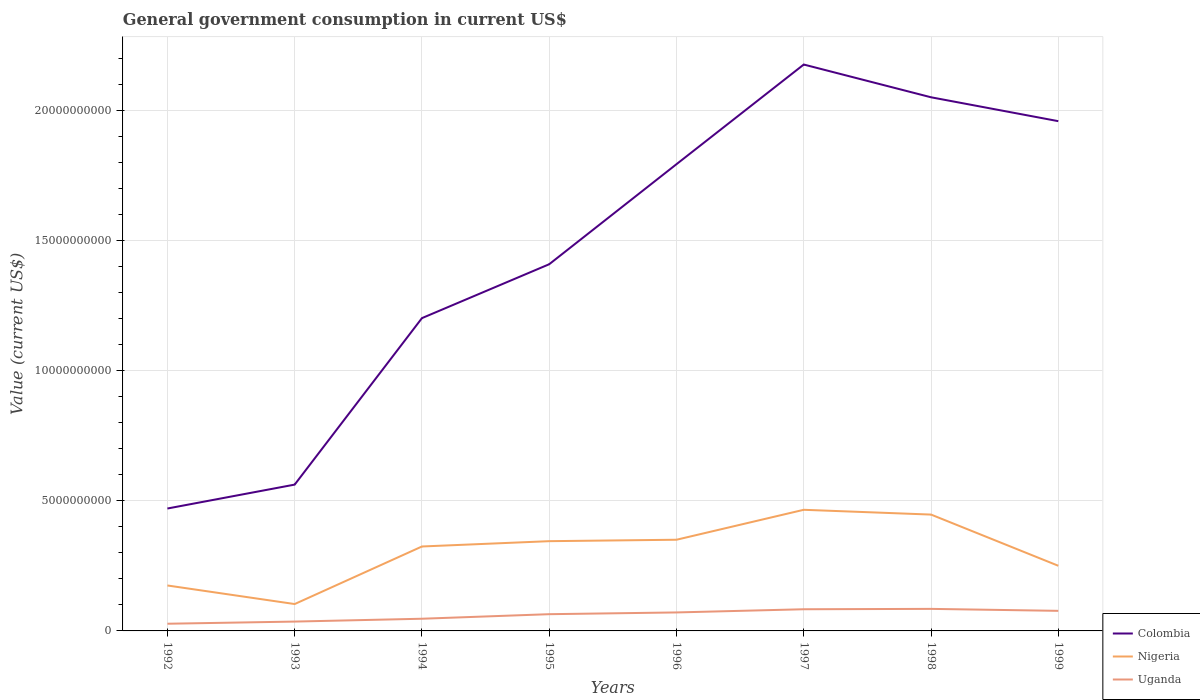Across all years, what is the maximum government conusmption in Uganda?
Provide a succinct answer. 2.76e+08. In which year was the government conusmption in Nigeria maximum?
Your response must be concise. 1993. What is the total government conusmption in Colombia in the graph?
Your answer should be compact. -1.61e+1. What is the difference between the highest and the second highest government conusmption in Nigeria?
Your answer should be compact. 3.62e+09. What is the difference between the highest and the lowest government conusmption in Uganda?
Your answer should be very brief. 5. How many lines are there?
Provide a succinct answer. 3. How many years are there in the graph?
Your answer should be very brief. 8. What is the difference between two consecutive major ticks on the Y-axis?
Your response must be concise. 5.00e+09. Does the graph contain any zero values?
Ensure brevity in your answer.  No. Does the graph contain grids?
Provide a short and direct response. Yes. Where does the legend appear in the graph?
Provide a succinct answer. Bottom right. How many legend labels are there?
Ensure brevity in your answer.  3. How are the legend labels stacked?
Make the answer very short. Vertical. What is the title of the graph?
Offer a terse response. General government consumption in current US$. What is the label or title of the Y-axis?
Your answer should be very brief. Value (current US$). What is the Value (current US$) in Colombia in 1992?
Offer a terse response. 4.71e+09. What is the Value (current US$) of Nigeria in 1992?
Provide a succinct answer. 1.75e+09. What is the Value (current US$) of Uganda in 1992?
Your answer should be very brief. 2.76e+08. What is the Value (current US$) of Colombia in 1993?
Provide a succinct answer. 5.62e+09. What is the Value (current US$) of Nigeria in 1993?
Your response must be concise. 1.03e+09. What is the Value (current US$) in Uganda in 1993?
Provide a short and direct response. 3.59e+08. What is the Value (current US$) in Colombia in 1994?
Offer a very short reply. 1.20e+1. What is the Value (current US$) of Nigeria in 1994?
Offer a very short reply. 3.25e+09. What is the Value (current US$) of Uganda in 1994?
Offer a very short reply. 4.69e+08. What is the Value (current US$) in Colombia in 1995?
Provide a short and direct response. 1.41e+1. What is the Value (current US$) in Nigeria in 1995?
Make the answer very short. 3.45e+09. What is the Value (current US$) in Uganda in 1995?
Ensure brevity in your answer.  6.43e+08. What is the Value (current US$) of Colombia in 1996?
Offer a terse response. 1.79e+1. What is the Value (current US$) in Nigeria in 1996?
Give a very brief answer. 3.50e+09. What is the Value (current US$) in Uganda in 1996?
Keep it short and to the point. 7.11e+08. What is the Value (current US$) in Colombia in 1997?
Keep it short and to the point. 2.18e+1. What is the Value (current US$) of Nigeria in 1997?
Ensure brevity in your answer.  4.66e+09. What is the Value (current US$) of Uganda in 1997?
Provide a short and direct response. 8.33e+08. What is the Value (current US$) in Colombia in 1998?
Your answer should be compact. 2.05e+1. What is the Value (current US$) of Nigeria in 1998?
Provide a succinct answer. 4.47e+09. What is the Value (current US$) in Uganda in 1998?
Offer a terse response. 8.47e+08. What is the Value (current US$) of Colombia in 1999?
Provide a succinct answer. 1.96e+1. What is the Value (current US$) of Nigeria in 1999?
Offer a terse response. 2.50e+09. What is the Value (current US$) of Uganda in 1999?
Provide a short and direct response. 7.72e+08. Across all years, what is the maximum Value (current US$) in Colombia?
Your response must be concise. 2.18e+1. Across all years, what is the maximum Value (current US$) in Nigeria?
Keep it short and to the point. 4.66e+09. Across all years, what is the maximum Value (current US$) of Uganda?
Offer a very short reply. 8.47e+08. Across all years, what is the minimum Value (current US$) in Colombia?
Ensure brevity in your answer.  4.71e+09. Across all years, what is the minimum Value (current US$) of Nigeria?
Provide a short and direct response. 1.03e+09. Across all years, what is the minimum Value (current US$) of Uganda?
Your answer should be very brief. 2.76e+08. What is the total Value (current US$) of Colombia in the graph?
Your answer should be compact. 1.16e+11. What is the total Value (current US$) in Nigeria in the graph?
Your answer should be very brief. 2.46e+1. What is the total Value (current US$) of Uganda in the graph?
Keep it short and to the point. 4.91e+09. What is the difference between the Value (current US$) in Colombia in 1992 and that in 1993?
Make the answer very short. -9.19e+08. What is the difference between the Value (current US$) of Nigeria in 1992 and that in 1993?
Your answer should be compact. 7.14e+08. What is the difference between the Value (current US$) of Uganda in 1992 and that in 1993?
Your response must be concise. -8.31e+07. What is the difference between the Value (current US$) in Colombia in 1992 and that in 1994?
Ensure brevity in your answer.  -7.32e+09. What is the difference between the Value (current US$) in Nigeria in 1992 and that in 1994?
Make the answer very short. -1.50e+09. What is the difference between the Value (current US$) of Uganda in 1992 and that in 1994?
Give a very brief answer. -1.93e+08. What is the difference between the Value (current US$) in Colombia in 1992 and that in 1995?
Offer a very short reply. -9.39e+09. What is the difference between the Value (current US$) in Nigeria in 1992 and that in 1995?
Your response must be concise. -1.70e+09. What is the difference between the Value (current US$) of Uganda in 1992 and that in 1995?
Your answer should be compact. -3.67e+08. What is the difference between the Value (current US$) in Colombia in 1992 and that in 1996?
Your answer should be compact. -1.32e+1. What is the difference between the Value (current US$) in Nigeria in 1992 and that in 1996?
Make the answer very short. -1.76e+09. What is the difference between the Value (current US$) in Uganda in 1992 and that in 1996?
Offer a very short reply. -4.35e+08. What is the difference between the Value (current US$) in Colombia in 1992 and that in 1997?
Give a very brief answer. -1.71e+1. What is the difference between the Value (current US$) of Nigeria in 1992 and that in 1997?
Offer a terse response. -2.91e+09. What is the difference between the Value (current US$) in Uganda in 1992 and that in 1997?
Offer a terse response. -5.57e+08. What is the difference between the Value (current US$) in Colombia in 1992 and that in 1998?
Make the answer very short. -1.58e+1. What is the difference between the Value (current US$) in Nigeria in 1992 and that in 1998?
Offer a terse response. -2.73e+09. What is the difference between the Value (current US$) in Uganda in 1992 and that in 1998?
Offer a very short reply. -5.71e+08. What is the difference between the Value (current US$) in Colombia in 1992 and that in 1999?
Offer a very short reply. -1.49e+1. What is the difference between the Value (current US$) of Nigeria in 1992 and that in 1999?
Your answer should be compact. -7.58e+08. What is the difference between the Value (current US$) in Uganda in 1992 and that in 1999?
Offer a terse response. -4.96e+08. What is the difference between the Value (current US$) of Colombia in 1993 and that in 1994?
Provide a succinct answer. -6.40e+09. What is the difference between the Value (current US$) of Nigeria in 1993 and that in 1994?
Make the answer very short. -2.21e+09. What is the difference between the Value (current US$) in Uganda in 1993 and that in 1994?
Offer a very short reply. -1.10e+08. What is the difference between the Value (current US$) of Colombia in 1993 and that in 1995?
Offer a terse response. -8.47e+09. What is the difference between the Value (current US$) in Nigeria in 1993 and that in 1995?
Keep it short and to the point. -2.42e+09. What is the difference between the Value (current US$) in Uganda in 1993 and that in 1995?
Provide a succinct answer. -2.84e+08. What is the difference between the Value (current US$) of Colombia in 1993 and that in 1996?
Provide a succinct answer. -1.23e+1. What is the difference between the Value (current US$) of Nigeria in 1993 and that in 1996?
Offer a very short reply. -2.47e+09. What is the difference between the Value (current US$) in Uganda in 1993 and that in 1996?
Give a very brief answer. -3.52e+08. What is the difference between the Value (current US$) in Colombia in 1993 and that in 1997?
Provide a succinct answer. -1.61e+1. What is the difference between the Value (current US$) of Nigeria in 1993 and that in 1997?
Your response must be concise. -3.62e+09. What is the difference between the Value (current US$) of Uganda in 1993 and that in 1997?
Ensure brevity in your answer.  -4.74e+08. What is the difference between the Value (current US$) of Colombia in 1993 and that in 1998?
Offer a terse response. -1.49e+1. What is the difference between the Value (current US$) of Nigeria in 1993 and that in 1998?
Give a very brief answer. -3.44e+09. What is the difference between the Value (current US$) of Uganda in 1993 and that in 1998?
Provide a short and direct response. -4.88e+08. What is the difference between the Value (current US$) in Colombia in 1993 and that in 1999?
Make the answer very short. -1.40e+1. What is the difference between the Value (current US$) in Nigeria in 1993 and that in 1999?
Make the answer very short. -1.47e+09. What is the difference between the Value (current US$) in Uganda in 1993 and that in 1999?
Your answer should be very brief. -4.13e+08. What is the difference between the Value (current US$) in Colombia in 1994 and that in 1995?
Keep it short and to the point. -2.07e+09. What is the difference between the Value (current US$) in Nigeria in 1994 and that in 1995?
Ensure brevity in your answer.  -2.05e+08. What is the difference between the Value (current US$) of Uganda in 1994 and that in 1995?
Provide a succinct answer. -1.75e+08. What is the difference between the Value (current US$) of Colombia in 1994 and that in 1996?
Ensure brevity in your answer.  -5.92e+09. What is the difference between the Value (current US$) in Nigeria in 1994 and that in 1996?
Offer a terse response. -2.59e+08. What is the difference between the Value (current US$) of Uganda in 1994 and that in 1996?
Make the answer very short. -2.42e+08. What is the difference between the Value (current US$) of Colombia in 1994 and that in 1997?
Provide a short and direct response. -9.75e+09. What is the difference between the Value (current US$) in Nigeria in 1994 and that in 1997?
Provide a succinct answer. -1.41e+09. What is the difference between the Value (current US$) of Uganda in 1994 and that in 1997?
Make the answer very short. -3.65e+08. What is the difference between the Value (current US$) in Colombia in 1994 and that in 1998?
Keep it short and to the point. -8.49e+09. What is the difference between the Value (current US$) in Nigeria in 1994 and that in 1998?
Your answer should be compact. -1.23e+09. What is the difference between the Value (current US$) of Uganda in 1994 and that in 1998?
Provide a short and direct response. -3.79e+08. What is the difference between the Value (current US$) in Colombia in 1994 and that in 1999?
Provide a succinct answer. -7.57e+09. What is the difference between the Value (current US$) in Nigeria in 1994 and that in 1999?
Make the answer very short. 7.41e+08. What is the difference between the Value (current US$) in Uganda in 1994 and that in 1999?
Your answer should be compact. -3.03e+08. What is the difference between the Value (current US$) in Colombia in 1995 and that in 1996?
Make the answer very short. -3.85e+09. What is the difference between the Value (current US$) in Nigeria in 1995 and that in 1996?
Ensure brevity in your answer.  -5.49e+07. What is the difference between the Value (current US$) of Uganda in 1995 and that in 1996?
Ensure brevity in your answer.  -6.73e+07. What is the difference between the Value (current US$) in Colombia in 1995 and that in 1997?
Offer a terse response. -7.68e+09. What is the difference between the Value (current US$) of Nigeria in 1995 and that in 1997?
Keep it short and to the point. -1.21e+09. What is the difference between the Value (current US$) in Uganda in 1995 and that in 1997?
Offer a terse response. -1.90e+08. What is the difference between the Value (current US$) in Colombia in 1995 and that in 1998?
Your answer should be very brief. -6.42e+09. What is the difference between the Value (current US$) in Nigeria in 1995 and that in 1998?
Your answer should be very brief. -1.02e+09. What is the difference between the Value (current US$) in Uganda in 1995 and that in 1998?
Offer a terse response. -2.04e+08. What is the difference between the Value (current US$) in Colombia in 1995 and that in 1999?
Your answer should be compact. -5.50e+09. What is the difference between the Value (current US$) in Nigeria in 1995 and that in 1999?
Offer a terse response. 9.45e+08. What is the difference between the Value (current US$) of Uganda in 1995 and that in 1999?
Your answer should be very brief. -1.28e+08. What is the difference between the Value (current US$) of Colombia in 1996 and that in 1997?
Offer a very short reply. -3.83e+09. What is the difference between the Value (current US$) in Nigeria in 1996 and that in 1997?
Offer a terse response. -1.15e+09. What is the difference between the Value (current US$) in Uganda in 1996 and that in 1997?
Provide a succinct answer. -1.23e+08. What is the difference between the Value (current US$) of Colombia in 1996 and that in 1998?
Your answer should be compact. -2.57e+09. What is the difference between the Value (current US$) of Nigeria in 1996 and that in 1998?
Your answer should be compact. -9.67e+08. What is the difference between the Value (current US$) in Uganda in 1996 and that in 1998?
Ensure brevity in your answer.  -1.37e+08. What is the difference between the Value (current US$) in Colombia in 1996 and that in 1999?
Your response must be concise. -1.65e+09. What is the difference between the Value (current US$) in Nigeria in 1996 and that in 1999?
Your answer should be very brief. 1.00e+09. What is the difference between the Value (current US$) in Uganda in 1996 and that in 1999?
Provide a succinct answer. -6.10e+07. What is the difference between the Value (current US$) in Colombia in 1997 and that in 1998?
Your answer should be very brief. 1.26e+09. What is the difference between the Value (current US$) of Nigeria in 1997 and that in 1998?
Provide a succinct answer. 1.84e+08. What is the difference between the Value (current US$) in Uganda in 1997 and that in 1998?
Your response must be concise. -1.40e+07. What is the difference between the Value (current US$) of Colombia in 1997 and that in 1999?
Keep it short and to the point. 2.18e+09. What is the difference between the Value (current US$) in Nigeria in 1997 and that in 1999?
Give a very brief answer. 2.15e+09. What is the difference between the Value (current US$) of Uganda in 1997 and that in 1999?
Offer a very short reply. 6.16e+07. What is the difference between the Value (current US$) of Colombia in 1998 and that in 1999?
Your answer should be very brief. 9.18e+08. What is the difference between the Value (current US$) in Nigeria in 1998 and that in 1999?
Provide a succinct answer. 1.97e+09. What is the difference between the Value (current US$) of Uganda in 1998 and that in 1999?
Offer a terse response. 7.56e+07. What is the difference between the Value (current US$) in Colombia in 1992 and the Value (current US$) in Nigeria in 1993?
Offer a very short reply. 3.67e+09. What is the difference between the Value (current US$) of Colombia in 1992 and the Value (current US$) of Uganda in 1993?
Provide a succinct answer. 4.35e+09. What is the difference between the Value (current US$) in Nigeria in 1992 and the Value (current US$) in Uganda in 1993?
Your response must be concise. 1.39e+09. What is the difference between the Value (current US$) of Colombia in 1992 and the Value (current US$) of Nigeria in 1994?
Provide a short and direct response. 1.46e+09. What is the difference between the Value (current US$) in Colombia in 1992 and the Value (current US$) in Uganda in 1994?
Keep it short and to the point. 4.24e+09. What is the difference between the Value (current US$) in Nigeria in 1992 and the Value (current US$) in Uganda in 1994?
Your response must be concise. 1.28e+09. What is the difference between the Value (current US$) in Colombia in 1992 and the Value (current US$) in Nigeria in 1995?
Provide a succinct answer. 1.26e+09. What is the difference between the Value (current US$) of Colombia in 1992 and the Value (current US$) of Uganda in 1995?
Your answer should be very brief. 4.06e+09. What is the difference between the Value (current US$) of Nigeria in 1992 and the Value (current US$) of Uganda in 1995?
Offer a terse response. 1.10e+09. What is the difference between the Value (current US$) of Colombia in 1992 and the Value (current US$) of Nigeria in 1996?
Your answer should be compact. 1.20e+09. What is the difference between the Value (current US$) in Colombia in 1992 and the Value (current US$) in Uganda in 1996?
Provide a succinct answer. 3.99e+09. What is the difference between the Value (current US$) of Nigeria in 1992 and the Value (current US$) of Uganda in 1996?
Offer a very short reply. 1.04e+09. What is the difference between the Value (current US$) in Colombia in 1992 and the Value (current US$) in Nigeria in 1997?
Ensure brevity in your answer.  4.93e+07. What is the difference between the Value (current US$) of Colombia in 1992 and the Value (current US$) of Uganda in 1997?
Make the answer very short. 3.87e+09. What is the difference between the Value (current US$) of Nigeria in 1992 and the Value (current US$) of Uganda in 1997?
Your answer should be compact. 9.14e+08. What is the difference between the Value (current US$) in Colombia in 1992 and the Value (current US$) in Nigeria in 1998?
Ensure brevity in your answer.  2.33e+08. What is the difference between the Value (current US$) in Colombia in 1992 and the Value (current US$) in Uganda in 1998?
Offer a terse response. 3.86e+09. What is the difference between the Value (current US$) of Nigeria in 1992 and the Value (current US$) of Uganda in 1998?
Give a very brief answer. 9.00e+08. What is the difference between the Value (current US$) in Colombia in 1992 and the Value (current US$) in Nigeria in 1999?
Your answer should be very brief. 2.20e+09. What is the difference between the Value (current US$) in Colombia in 1992 and the Value (current US$) in Uganda in 1999?
Keep it short and to the point. 3.93e+09. What is the difference between the Value (current US$) of Nigeria in 1992 and the Value (current US$) of Uganda in 1999?
Offer a terse response. 9.75e+08. What is the difference between the Value (current US$) of Colombia in 1993 and the Value (current US$) of Nigeria in 1994?
Keep it short and to the point. 2.38e+09. What is the difference between the Value (current US$) of Colombia in 1993 and the Value (current US$) of Uganda in 1994?
Make the answer very short. 5.16e+09. What is the difference between the Value (current US$) in Nigeria in 1993 and the Value (current US$) in Uganda in 1994?
Ensure brevity in your answer.  5.64e+08. What is the difference between the Value (current US$) in Colombia in 1993 and the Value (current US$) in Nigeria in 1995?
Your response must be concise. 2.17e+09. What is the difference between the Value (current US$) of Colombia in 1993 and the Value (current US$) of Uganda in 1995?
Offer a terse response. 4.98e+09. What is the difference between the Value (current US$) of Nigeria in 1993 and the Value (current US$) of Uganda in 1995?
Your answer should be compact. 3.90e+08. What is the difference between the Value (current US$) in Colombia in 1993 and the Value (current US$) in Nigeria in 1996?
Offer a terse response. 2.12e+09. What is the difference between the Value (current US$) in Colombia in 1993 and the Value (current US$) in Uganda in 1996?
Give a very brief answer. 4.91e+09. What is the difference between the Value (current US$) in Nigeria in 1993 and the Value (current US$) in Uganda in 1996?
Your answer should be very brief. 3.22e+08. What is the difference between the Value (current US$) in Colombia in 1993 and the Value (current US$) in Nigeria in 1997?
Keep it short and to the point. 9.68e+08. What is the difference between the Value (current US$) in Colombia in 1993 and the Value (current US$) in Uganda in 1997?
Offer a terse response. 4.79e+09. What is the difference between the Value (current US$) of Nigeria in 1993 and the Value (current US$) of Uganda in 1997?
Offer a very short reply. 2.00e+08. What is the difference between the Value (current US$) in Colombia in 1993 and the Value (current US$) in Nigeria in 1998?
Your response must be concise. 1.15e+09. What is the difference between the Value (current US$) of Colombia in 1993 and the Value (current US$) of Uganda in 1998?
Ensure brevity in your answer.  4.78e+09. What is the difference between the Value (current US$) in Nigeria in 1993 and the Value (current US$) in Uganda in 1998?
Your response must be concise. 1.86e+08. What is the difference between the Value (current US$) in Colombia in 1993 and the Value (current US$) in Nigeria in 1999?
Your answer should be very brief. 3.12e+09. What is the difference between the Value (current US$) in Colombia in 1993 and the Value (current US$) in Uganda in 1999?
Keep it short and to the point. 4.85e+09. What is the difference between the Value (current US$) of Nigeria in 1993 and the Value (current US$) of Uganda in 1999?
Provide a short and direct response. 2.61e+08. What is the difference between the Value (current US$) in Colombia in 1994 and the Value (current US$) in Nigeria in 1995?
Offer a very short reply. 8.57e+09. What is the difference between the Value (current US$) of Colombia in 1994 and the Value (current US$) of Uganda in 1995?
Make the answer very short. 1.14e+1. What is the difference between the Value (current US$) in Nigeria in 1994 and the Value (current US$) in Uganda in 1995?
Offer a very short reply. 2.60e+09. What is the difference between the Value (current US$) in Colombia in 1994 and the Value (current US$) in Nigeria in 1996?
Your response must be concise. 8.52e+09. What is the difference between the Value (current US$) in Colombia in 1994 and the Value (current US$) in Uganda in 1996?
Give a very brief answer. 1.13e+1. What is the difference between the Value (current US$) of Nigeria in 1994 and the Value (current US$) of Uganda in 1996?
Your answer should be compact. 2.53e+09. What is the difference between the Value (current US$) in Colombia in 1994 and the Value (current US$) in Nigeria in 1997?
Your answer should be compact. 7.37e+09. What is the difference between the Value (current US$) in Colombia in 1994 and the Value (current US$) in Uganda in 1997?
Make the answer very short. 1.12e+1. What is the difference between the Value (current US$) in Nigeria in 1994 and the Value (current US$) in Uganda in 1997?
Your answer should be very brief. 2.41e+09. What is the difference between the Value (current US$) of Colombia in 1994 and the Value (current US$) of Nigeria in 1998?
Your answer should be compact. 7.55e+09. What is the difference between the Value (current US$) in Colombia in 1994 and the Value (current US$) in Uganda in 1998?
Give a very brief answer. 1.12e+1. What is the difference between the Value (current US$) in Nigeria in 1994 and the Value (current US$) in Uganda in 1998?
Keep it short and to the point. 2.40e+09. What is the difference between the Value (current US$) in Colombia in 1994 and the Value (current US$) in Nigeria in 1999?
Make the answer very short. 9.52e+09. What is the difference between the Value (current US$) in Colombia in 1994 and the Value (current US$) in Uganda in 1999?
Your response must be concise. 1.13e+1. What is the difference between the Value (current US$) in Nigeria in 1994 and the Value (current US$) in Uganda in 1999?
Provide a short and direct response. 2.47e+09. What is the difference between the Value (current US$) of Colombia in 1995 and the Value (current US$) of Nigeria in 1996?
Offer a terse response. 1.06e+1. What is the difference between the Value (current US$) in Colombia in 1995 and the Value (current US$) in Uganda in 1996?
Your answer should be compact. 1.34e+1. What is the difference between the Value (current US$) in Nigeria in 1995 and the Value (current US$) in Uganda in 1996?
Keep it short and to the point. 2.74e+09. What is the difference between the Value (current US$) in Colombia in 1995 and the Value (current US$) in Nigeria in 1997?
Make the answer very short. 9.44e+09. What is the difference between the Value (current US$) of Colombia in 1995 and the Value (current US$) of Uganda in 1997?
Ensure brevity in your answer.  1.33e+1. What is the difference between the Value (current US$) of Nigeria in 1995 and the Value (current US$) of Uganda in 1997?
Provide a short and direct response. 2.62e+09. What is the difference between the Value (current US$) in Colombia in 1995 and the Value (current US$) in Nigeria in 1998?
Give a very brief answer. 9.62e+09. What is the difference between the Value (current US$) of Colombia in 1995 and the Value (current US$) of Uganda in 1998?
Ensure brevity in your answer.  1.32e+1. What is the difference between the Value (current US$) in Nigeria in 1995 and the Value (current US$) in Uganda in 1998?
Keep it short and to the point. 2.60e+09. What is the difference between the Value (current US$) of Colombia in 1995 and the Value (current US$) of Nigeria in 1999?
Offer a terse response. 1.16e+1. What is the difference between the Value (current US$) of Colombia in 1995 and the Value (current US$) of Uganda in 1999?
Provide a short and direct response. 1.33e+1. What is the difference between the Value (current US$) of Nigeria in 1995 and the Value (current US$) of Uganda in 1999?
Your answer should be very brief. 2.68e+09. What is the difference between the Value (current US$) in Colombia in 1996 and the Value (current US$) in Nigeria in 1997?
Offer a terse response. 1.33e+1. What is the difference between the Value (current US$) in Colombia in 1996 and the Value (current US$) in Uganda in 1997?
Provide a succinct answer. 1.71e+1. What is the difference between the Value (current US$) in Nigeria in 1996 and the Value (current US$) in Uganda in 1997?
Your answer should be very brief. 2.67e+09. What is the difference between the Value (current US$) in Colombia in 1996 and the Value (current US$) in Nigeria in 1998?
Provide a succinct answer. 1.35e+1. What is the difference between the Value (current US$) in Colombia in 1996 and the Value (current US$) in Uganda in 1998?
Keep it short and to the point. 1.71e+1. What is the difference between the Value (current US$) of Nigeria in 1996 and the Value (current US$) of Uganda in 1998?
Provide a short and direct response. 2.66e+09. What is the difference between the Value (current US$) in Colombia in 1996 and the Value (current US$) in Nigeria in 1999?
Offer a very short reply. 1.54e+1. What is the difference between the Value (current US$) of Colombia in 1996 and the Value (current US$) of Uganda in 1999?
Offer a terse response. 1.72e+1. What is the difference between the Value (current US$) in Nigeria in 1996 and the Value (current US$) in Uganda in 1999?
Offer a very short reply. 2.73e+09. What is the difference between the Value (current US$) in Colombia in 1997 and the Value (current US$) in Nigeria in 1998?
Provide a succinct answer. 1.73e+1. What is the difference between the Value (current US$) in Colombia in 1997 and the Value (current US$) in Uganda in 1998?
Keep it short and to the point. 2.09e+1. What is the difference between the Value (current US$) in Nigeria in 1997 and the Value (current US$) in Uganda in 1998?
Offer a very short reply. 3.81e+09. What is the difference between the Value (current US$) in Colombia in 1997 and the Value (current US$) in Nigeria in 1999?
Ensure brevity in your answer.  1.93e+1. What is the difference between the Value (current US$) of Colombia in 1997 and the Value (current US$) of Uganda in 1999?
Your response must be concise. 2.10e+1. What is the difference between the Value (current US$) in Nigeria in 1997 and the Value (current US$) in Uganda in 1999?
Make the answer very short. 3.88e+09. What is the difference between the Value (current US$) of Colombia in 1998 and the Value (current US$) of Nigeria in 1999?
Provide a succinct answer. 1.80e+1. What is the difference between the Value (current US$) of Colombia in 1998 and the Value (current US$) of Uganda in 1999?
Make the answer very short. 1.97e+1. What is the difference between the Value (current US$) of Nigeria in 1998 and the Value (current US$) of Uganda in 1999?
Ensure brevity in your answer.  3.70e+09. What is the average Value (current US$) of Colombia per year?
Provide a succinct answer. 1.45e+1. What is the average Value (current US$) in Nigeria per year?
Keep it short and to the point. 3.08e+09. What is the average Value (current US$) in Uganda per year?
Your answer should be very brief. 6.14e+08. In the year 1992, what is the difference between the Value (current US$) of Colombia and Value (current US$) of Nigeria?
Your response must be concise. 2.96e+09. In the year 1992, what is the difference between the Value (current US$) of Colombia and Value (current US$) of Uganda?
Ensure brevity in your answer.  4.43e+09. In the year 1992, what is the difference between the Value (current US$) in Nigeria and Value (current US$) in Uganda?
Your answer should be compact. 1.47e+09. In the year 1993, what is the difference between the Value (current US$) in Colombia and Value (current US$) in Nigeria?
Your answer should be very brief. 4.59e+09. In the year 1993, what is the difference between the Value (current US$) of Colombia and Value (current US$) of Uganda?
Give a very brief answer. 5.26e+09. In the year 1993, what is the difference between the Value (current US$) in Nigeria and Value (current US$) in Uganda?
Offer a very short reply. 6.74e+08. In the year 1994, what is the difference between the Value (current US$) in Colombia and Value (current US$) in Nigeria?
Ensure brevity in your answer.  8.78e+09. In the year 1994, what is the difference between the Value (current US$) of Colombia and Value (current US$) of Uganda?
Your response must be concise. 1.16e+1. In the year 1994, what is the difference between the Value (current US$) in Nigeria and Value (current US$) in Uganda?
Give a very brief answer. 2.78e+09. In the year 1995, what is the difference between the Value (current US$) of Colombia and Value (current US$) of Nigeria?
Make the answer very short. 1.06e+1. In the year 1995, what is the difference between the Value (current US$) of Colombia and Value (current US$) of Uganda?
Make the answer very short. 1.35e+1. In the year 1995, what is the difference between the Value (current US$) in Nigeria and Value (current US$) in Uganda?
Provide a short and direct response. 2.81e+09. In the year 1996, what is the difference between the Value (current US$) in Colombia and Value (current US$) in Nigeria?
Provide a short and direct response. 1.44e+1. In the year 1996, what is the difference between the Value (current US$) in Colombia and Value (current US$) in Uganda?
Provide a succinct answer. 1.72e+1. In the year 1996, what is the difference between the Value (current US$) in Nigeria and Value (current US$) in Uganda?
Provide a succinct answer. 2.79e+09. In the year 1997, what is the difference between the Value (current US$) in Colombia and Value (current US$) in Nigeria?
Your answer should be very brief. 1.71e+1. In the year 1997, what is the difference between the Value (current US$) of Colombia and Value (current US$) of Uganda?
Offer a very short reply. 2.09e+1. In the year 1997, what is the difference between the Value (current US$) of Nigeria and Value (current US$) of Uganda?
Ensure brevity in your answer.  3.82e+09. In the year 1998, what is the difference between the Value (current US$) of Colombia and Value (current US$) of Nigeria?
Your response must be concise. 1.60e+1. In the year 1998, what is the difference between the Value (current US$) in Colombia and Value (current US$) in Uganda?
Give a very brief answer. 1.97e+1. In the year 1998, what is the difference between the Value (current US$) of Nigeria and Value (current US$) of Uganda?
Your answer should be very brief. 3.62e+09. In the year 1999, what is the difference between the Value (current US$) in Colombia and Value (current US$) in Nigeria?
Offer a terse response. 1.71e+1. In the year 1999, what is the difference between the Value (current US$) in Colombia and Value (current US$) in Uganda?
Provide a short and direct response. 1.88e+1. In the year 1999, what is the difference between the Value (current US$) in Nigeria and Value (current US$) in Uganda?
Make the answer very short. 1.73e+09. What is the ratio of the Value (current US$) in Colombia in 1992 to that in 1993?
Give a very brief answer. 0.84. What is the ratio of the Value (current US$) in Nigeria in 1992 to that in 1993?
Make the answer very short. 1.69. What is the ratio of the Value (current US$) in Uganda in 1992 to that in 1993?
Offer a terse response. 0.77. What is the ratio of the Value (current US$) of Colombia in 1992 to that in 1994?
Provide a succinct answer. 0.39. What is the ratio of the Value (current US$) in Nigeria in 1992 to that in 1994?
Keep it short and to the point. 0.54. What is the ratio of the Value (current US$) in Uganda in 1992 to that in 1994?
Provide a short and direct response. 0.59. What is the ratio of the Value (current US$) in Colombia in 1992 to that in 1995?
Make the answer very short. 0.33. What is the ratio of the Value (current US$) of Nigeria in 1992 to that in 1995?
Your answer should be very brief. 0.51. What is the ratio of the Value (current US$) of Uganda in 1992 to that in 1995?
Your answer should be compact. 0.43. What is the ratio of the Value (current US$) in Colombia in 1992 to that in 1996?
Your response must be concise. 0.26. What is the ratio of the Value (current US$) in Nigeria in 1992 to that in 1996?
Make the answer very short. 0.5. What is the ratio of the Value (current US$) of Uganda in 1992 to that in 1996?
Offer a very short reply. 0.39. What is the ratio of the Value (current US$) of Colombia in 1992 to that in 1997?
Offer a very short reply. 0.22. What is the ratio of the Value (current US$) in Nigeria in 1992 to that in 1997?
Give a very brief answer. 0.38. What is the ratio of the Value (current US$) in Uganda in 1992 to that in 1997?
Ensure brevity in your answer.  0.33. What is the ratio of the Value (current US$) of Colombia in 1992 to that in 1998?
Ensure brevity in your answer.  0.23. What is the ratio of the Value (current US$) in Nigeria in 1992 to that in 1998?
Keep it short and to the point. 0.39. What is the ratio of the Value (current US$) in Uganda in 1992 to that in 1998?
Provide a short and direct response. 0.33. What is the ratio of the Value (current US$) in Colombia in 1992 to that in 1999?
Offer a very short reply. 0.24. What is the ratio of the Value (current US$) of Nigeria in 1992 to that in 1999?
Make the answer very short. 0.7. What is the ratio of the Value (current US$) in Uganda in 1992 to that in 1999?
Your answer should be very brief. 0.36. What is the ratio of the Value (current US$) of Colombia in 1993 to that in 1994?
Your answer should be compact. 0.47. What is the ratio of the Value (current US$) in Nigeria in 1993 to that in 1994?
Offer a very short reply. 0.32. What is the ratio of the Value (current US$) of Uganda in 1993 to that in 1994?
Your answer should be very brief. 0.77. What is the ratio of the Value (current US$) of Colombia in 1993 to that in 1995?
Make the answer very short. 0.4. What is the ratio of the Value (current US$) of Nigeria in 1993 to that in 1995?
Keep it short and to the point. 0.3. What is the ratio of the Value (current US$) of Uganda in 1993 to that in 1995?
Your response must be concise. 0.56. What is the ratio of the Value (current US$) of Colombia in 1993 to that in 1996?
Give a very brief answer. 0.31. What is the ratio of the Value (current US$) of Nigeria in 1993 to that in 1996?
Your response must be concise. 0.29. What is the ratio of the Value (current US$) in Uganda in 1993 to that in 1996?
Your response must be concise. 0.51. What is the ratio of the Value (current US$) in Colombia in 1993 to that in 1997?
Offer a very short reply. 0.26. What is the ratio of the Value (current US$) of Nigeria in 1993 to that in 1997?
Your answer should be compact. 0.22. What is the ratio of the Value (current US$) of Uganda in 1993 to that in 1997?
Ensure brevity in your answer.  0.43. What is the ratio of the Value (current US$) in Colombia in 1993 to that in 1998?
Make the answer very short. 0.27. What is the ratio of the Value (current US$) in Nigeria in 1993 to that in 1998?
Keep it short and to the point. 0.23. What is the ratio of the Value (current US$) of Uganda in 1993 to that in 1998?
Ensure brevity in your answer.  0.42. What is the ratio of the Value (current US$) of Colombia in 1993 to that in 1999?
Ensure brevity in your answer.  0.29. What is the ratio of the Value (current US$) in Nigeria in 1993 to that in 1999?
Make the answer very short. 0.41. What is the ratio of the Value (current US$) in Uganda in 1993 to that in 1999?
Offer a terse response. 0.47. What is the ratio of the Value (current US$) in Colombia in 1994 to that in 1995?
Your answer should be compact. 0.85. What is the ratio of the Value (current US$) of Nigeria in 1994 to that in 1995?
Provide a succinct answer. 0.94. What is the ratio of the Value (current US$) in Uganda in 1994 to that in 1995?
Make the answer very short. 0.73. What is the ratio of the Value (current US$) of Colombia in 1994 to that in 1996?
Make the answer very short. 0.67. What is the ratio of the Value (current US$) of Nigeria in 1994 to that in 1996?
Keep it short and to the point. 0.93. What is the ratio of the Value (current US$) of Uganda in 1994 to that in 1996?
Keep it short and to the point. 0.66. What is the ratio of the Value (current US$) in Colombia in 1994 to that in 1997?
Offer a terse response. 0.55. What is the ratio of the Value (current US$) of Nigeria in 1994 to that in 1997?
Offer a terse response. 0.7. What is the ratio of the Value (current US$) of Uganda in 1994 to that in 1997?
Give a very brief answer. 0.56. What is the ratio of the Value (current US$) of Colombia in 1994 to that in 1998?
Make the answer very short. 0.59. What is the ratio of the Value (current US$) in Nigeria in 1994 to that in 1998?
Offer a terse response. 0.73. What is the ratio of the Value (current US$) in Uganda in 1994 to that in 1998?
Your answer should be very brief. 0.55. What is the ratio of the Value (current US$) of Colombia in 1994 to that in 1999?
Ensure brevity in your answer.  0.61. What is the ratio of the Value (current US$) of Nigeria in 1994 to that in 1999?
Your response must be concise. 1.3. What is the ratio of the Value (current US$) of Uganda in 1994 to that in 1999?
Make the answer very short. 0.61. What is the ratio of the Value (current US$) in Colombia in 1995 to that in 1996?
Keep it short and to the point. 0.79. What is the ratio of the Value (current US$) in Nigeria in 1995 to that in 1996?
Keep it short and to the point. 0.98. What is the ratio of the Value (current US$) in Uganda in 1995 to that in 1996?
Provide a short and direct response. 0.91. What is the ratio of the Value (current US$) in Colombia in 1995 to that in 1997?
Your response must be concise. 0.65. What is the ratio of the Value (current US$) of Nigeria in 1995 to that in 1997?
Offer a terse response. 0.74. What is the ratio of the Value (current US$) in Uganda in 1995 to that in 1997?
Offer a terse response. 0.77. What is the ratio of the Value (current US$) in Colombia in 1995 to that in 1998?
Provide a short and direct response. 0.69. What is the ratio of the Value (current US$) in Nigeria in 1995 to that in 1998?
Give a very brief answer. 0.77. What is the ratio of the Value (current US$) in Uganda in 1995 to that in 1998?
Offer a very short reply. 0.76. What is the ratio of the Value (current US$) in Colombia in 1995 to that in 1999?
Provide a succinct answer. 0.72. What is the ratio of the Value (current US$) of Nigeria in 1995 to that in 1999?
Give a very brief answer. 1.38. What is the ratio of the Value (current US$) in Uganda in 1995 to that in 1999?
Provide a short and direct response. 0.83. What is the ratio of the Value (current US$) of Colombia in 1996 to that in 1997?
Offer a terse response. 0.82. What is the ratio of the Value (current US$) in Nigeria in 1996 to that in 1997?
Offer a terse response. 0.75. What is the ratio of the Value (current US$) in Uganda in 1996 to that in 1997?
Make the answer very short. 0.85. What is the ratio of the Value (current US$) of Colombia in 1996 to that in 1998?
Your answer should be compact. 0.87. What is the ratio of the Value (current US$) in Nigeria in 1996 to that in 1998?
Your answer should be very brief. 0.78. What is the ratio of the Value (current US$) in Uganda in 1996 to that in 1998?
Give a very brief answer. 0.84. What is the ratio of the Value (current US$) of Colombia in 1996 to that in 1999?
Ensure brevity in your answer.  0.92. What is the ratio of the Value (current US$) of Nigeria in 1996 to that in 1999?
Your answer should be compact. 1.4. What is the ratio of the Value (current US$) of Uganda in 1996 to that in 1999?
Offer a terse response. 0.92. What is the ratio of the Value (current US$) of Colombia in 1997 to that in 1998?
Provide a short and direct response. 1.06. What is the ratio of the Value (current US$) in Nigeria in 1997 to that in 1998?
Offer a terse response. 1.04. What is the ratio of the Value (current US$) of Uganda in 1997 to that in 1998?
Ensure brevity in your answer.  0.98. What is the ratio of the Value (current US$) of Colombia in 1997 to that in 1999?
Give a very brief answer. 1.11. What is the ratio of the Value (current US$) of Nigeria in 1997 to that in 1999?
Your answer should be very brief. 1.86. What is the ratio of the Value (current US$) in Uganda in 1997 to that in 1999?
Provide a succinct answer. 1.08. What is the ratio of the Value (current US$) in Colombia in 1998 to that in 1999?
Make the answer very short. 1.05. What is the ratio of the Value (current US$) of Nigeria in 1998 to that in 1999?
Keep it short and to the point. 1.79. What is the ratio of the Value (current US$) in Uganda in 1998 to that in 1999?
Keep it short and to the point. 1.1. What is the difference between the highest and the second highest Value (current US$) of Colombia?
Give a very brief answer. 1.26e+09. What is the difference between the highest and the second highest Value (current US$) in Nigeria?
Give a very brief answer. 1.84e+08. What is the difference between the highest and the second highest Value (current US$) of Uganda?
Keep it short and to the point. 1.40e+07. What is the difference between the highest and the lowest Value (current US$) in Colombia?
Keep it short and to the point. 1.71e+1. What is the difference between the highest and the lowest Value (current US$) in Nigeria?
Your response must be concise. 3.62e+09. What is the difference between the highest and the lowest Value (current US$) of Uganda?
Your response must be concise. 5.71e+08. 